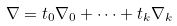Convert formula to latex. <formula><loc_0><loc_0><loc_500><loc_500>\nabla = t _ { 0 } \nabla _ { 0 } + \dots + t _ { k } \nabla _ { k }</formula> 